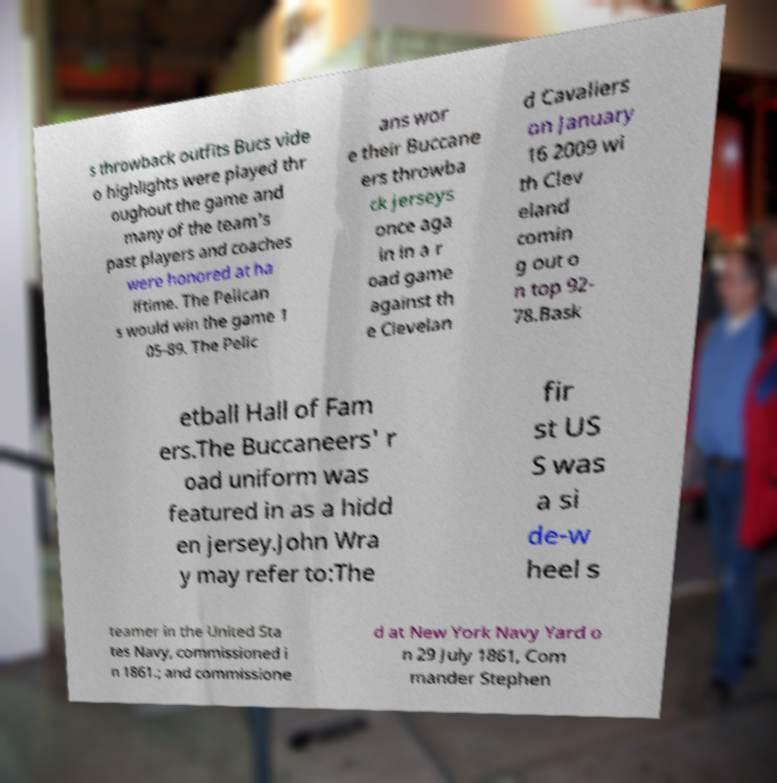Please read and relay the text visible in this image. What does it say? s throwback outfits Bucs vide o highlights were played thr oughout the game and many of the team's past players and coaches were honored at ha lftime. The Pelican s would win the game 1 05-89. The Pelic ans wor e their Buccane ers throwba ck jerseys once aga in in a r oad game against th e Clevelan d Cavaliers on January 16 2009 wi th Clev eland comin g out o n top 92- 78.Bask etball Hall of Fam ers.The Buccaneers' r oad uniform was featured in as a hidd en jersey.John Wra y may refer to:The fir st US S was a si de-w heel s teamer in the United Sta tes Navy, commissioned i n 1861.; and commissione d at New York Navy Yard o n 29 July 1861, Com mander Stephen 